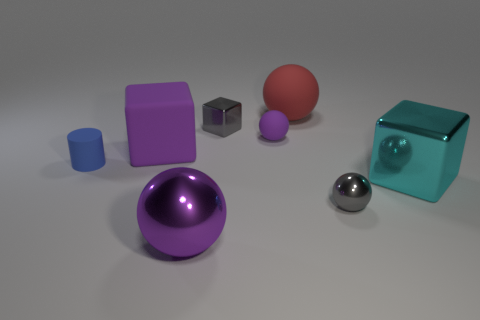Subtract all purple balls. How many were subtracted if there are1purple balls left? 1 Subtract all brown cylinders. How many purple spheres are left? 2 Subtract 1 cubes. How many cubes are left? 2 Add 2 purple metal things. How many objects exist? 10 Subtract all large shiny spheres. How many spheres are left? 3 Subtract all red spheres. How many spheres are left? 3 Subtract all blocks. How many objects are left? 5 Subtract all brown blocks. Subtract all brown cylinders. How many blocks are left? 3 Subtract all purple cubes. Subtract all tiny cylinders. How many objects are left? 6 Add 1 large matte spheres. How many large matte spheres are left? 2 